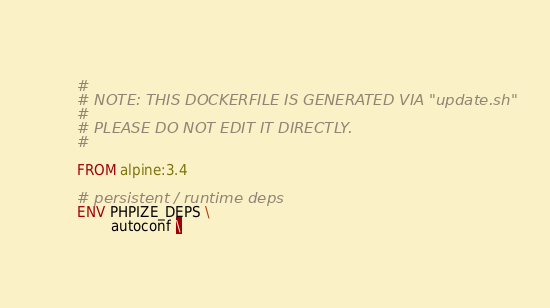Convert code to text. <code><loc_0><loc_0><loc_500><loc_500><_Dockerfile_>#
# NOTE: THIS DOCKERFILE IS GENERATED VIA "update.sh"
#
# PLEASE DO NOT EDIT IT DIRECTLY.
#

FROM alpine:3.4

# persistent / runtime deps
ENV PHPIZE_DEPS \
		autoconf \</code> 